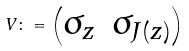<formula> <loc_0><loc_0><loc_500><loc_500>\ V \colon = \begin{pmatrix} \sigma _ { z } & \sigma _ { J ( z ) } \end{pmatrix}</formula> 